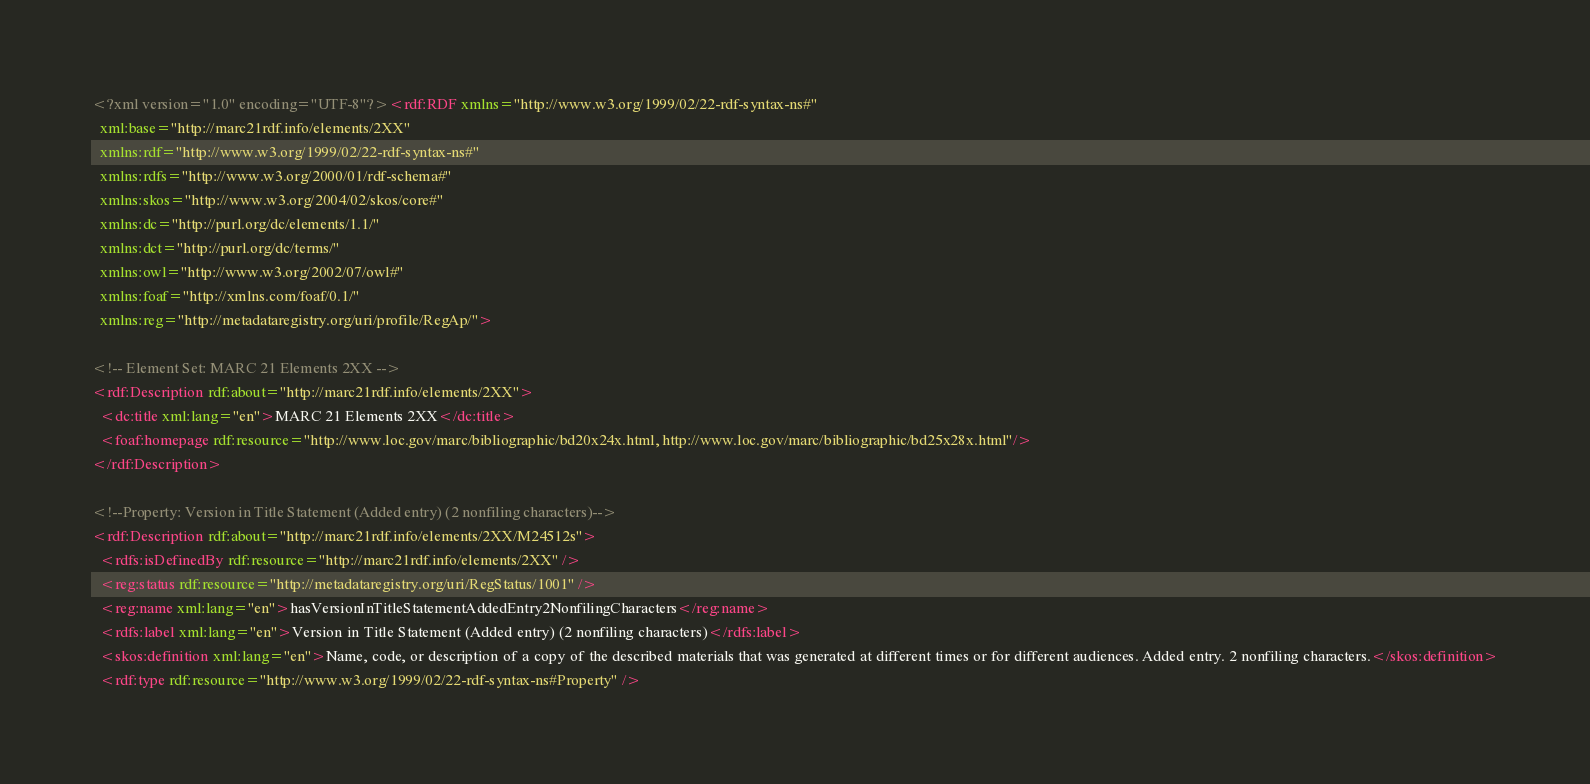<code> <loc_0><loc_0><loc_500><loc_500><_XML_><?xml version="1.0" encoding="UTF-8"?><rdf:RDF xmlns="http://www.w3.org/1999/02/22-rdf-syntax-ns#"
  xml:base="http://marc21rdf.info/elements/2XX"
  xmlns:rdf="http://www.w3.org/1999/02/22-rdf-syntax-ns#"
  xmlns:rdfs="http://www.w3.org/2000/01/rdf-schema#"
  xmlns:skos="http://www.w3.org/2004/02/skos/core#"
  xmlns:dc="http://purl.org/dc/elements/1.1/"
  xmlns:dct="http://purl.org/dc/terms/"
  xmlns:owl="http://www.w3.org/2002/07/owl#"
  xmlns:foaf="http://xmlns.com/foaf/0.1/"
  xmlns:reg="http://metadataregistry.org/uri/profile/RegAp/">

<!-- Element Set: MARC 21 Elements 2XX -->
<rdf:Description rdf:about="http://marc21rdf.info/elements/2XX">
  <dc:title xml:lang="en">MARC 21 Elements 2XX</dc:title>
  <foaf:homepage rdf:resource="http://www.loc.gov/marc/bibliographic/bd20x24x.html, http://www.loc.gov/marc/bibliographic/bd25x28x.html"/>
</rdf:Description>

<!--Property: Version in Title Statement (Added entry) (2 nonfiling characters)-->
<rdf:Description rdf:about="http://marc21rdf.info/elements/2XX/M24512s">
  <rdfs:isDefinedBy rdf:resource="http://marc21rdf.info/elements/2XX" />
  <reg:status rdf:resource="http://metadataregistry.org/uri/RegStatus/1001" />
  <reg:name xml:lang="en">hasVersionInTitleStatementAddedEntry2NonfilingCharacters</reg:name>
  <rdfs:label xml:lang="en">Version in Title Statement (Added entry) (2 nonfiling characters)</rdfs:label>
  <skos:definition xml:lang="en">Name, code, or description of a copy of the described materials that was generated at different times or for different audiences. Added entry. 2 nonfiling characters.</skos:definition>
  <rdf:type rdf:resource="http://www.w3.org/1999/02/22-rdf-syntax-ns#Property" /></code> 